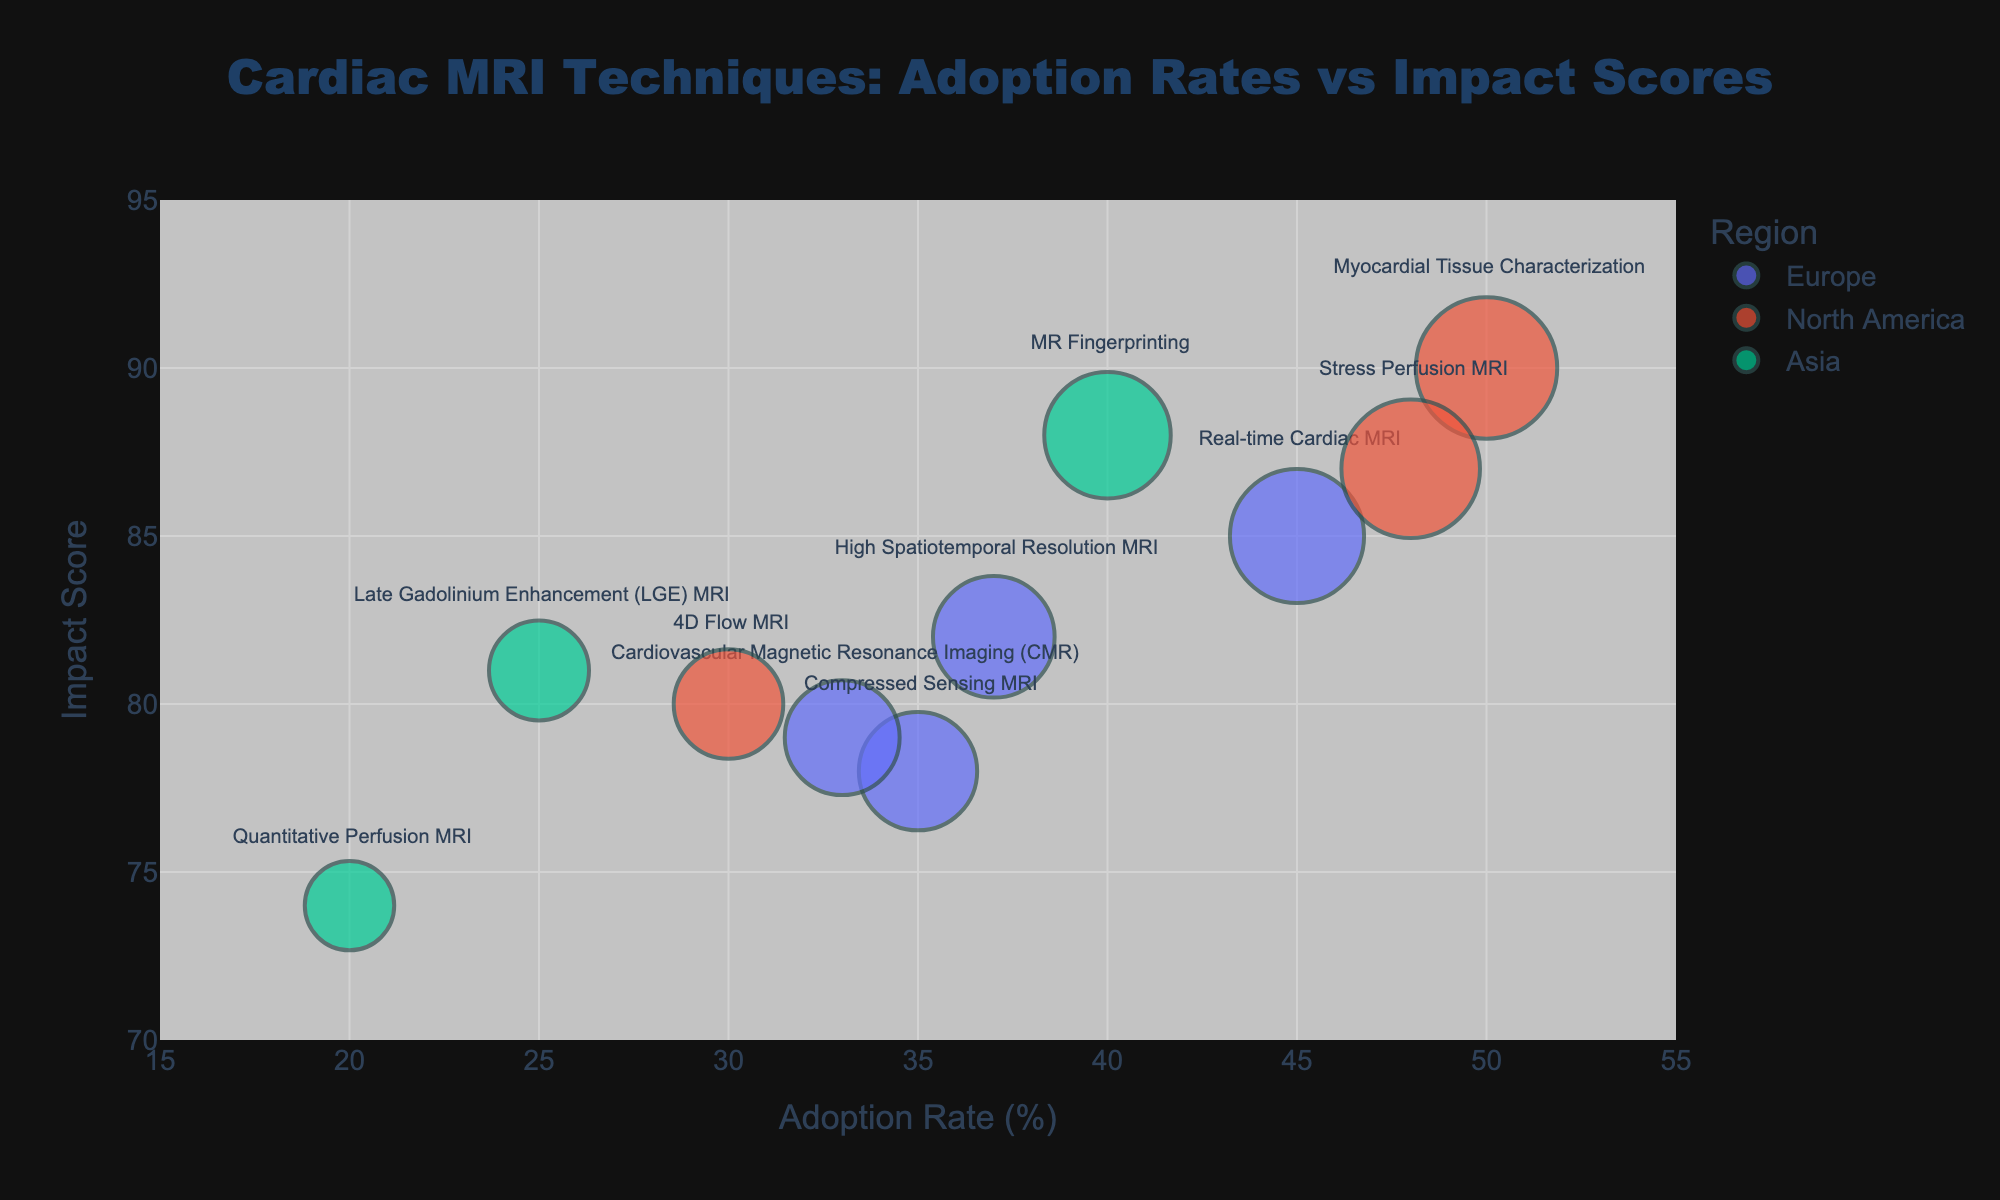How many unique techniques are depicted in the figure? There are a total of 10 unique techniques shown: Real-time Cardiac MRI, Compressed Sensing MRI, Myocardial Tissue Characterization, 4D Flow MRI, MR Fingerprinting, Quantitative Perfusion MRI, High Spatiotemporal Resolution MRI, Cardiovascular Magnetic Resonance Imaging (CMR), Stress Perfusion MRI, and Late Gadolinium Enhancement (LGE) MRI.
Answer: 10 Which region has the highest average Adoption Rate? To find the region with the highest average Adoption Rate, calculate the averages: Europe = (45+35+37+33)/4 = 37.5, North America = (50+30+48)/3 = 42.67, Asia = (40+20+25)/3 = 28.33. North America has the highest average Adoption Rate.
Answer: North America Which technique has the highest Impact Score? The highest Impact Score among the techniques is Myocardial Tissue Characterization with a score of 90.
Answer: Myocardial Tissue Characterization What is the range of Adoption Rates shown in the figure? The Adoption Rates range from the minimum value of 20% (Quantitative Perfusion MRI) to the maximum value of 50% (Myocardial Tissue Characterization). The range is 50 - 20 = 30%.
Answer: 30% Which country has the highest Adoption Rate for cardiac MRI techniques? The USA has the highest Adoption Rate for cardiac MRI techniques, with Myocardial Tissue Characterization at 50%.
Answer: USA What is the difference in Impact Scores between Real-time Cardiac MRI in Germany and Compressed Sensing MRI in France? The Impact Score for Real-time Cardiac MRI in Germany is 85, and for Compressed Sensing MRI in France is 78. The difference is 85 - 78 = 7.
Answer: 7 Are any techniques marked by all regions (Europe, North America, Asia) clustered closely together in terms of Impact Scores? By examining the bubble chart, it appears that techniques like Real-time Cardiac MRI (Europe: 85), Myocardial Tissue Characterization (North America: 90), and MR Fingerprinting (Asia: 88) are closely clustered around high Impact Scores (85-90).
Answer: Yes Which technique in Europe has the lowest Adoption Rate and what is its value? Cardiovascular Magnetic Resonance Imaging (CMR) in Sweden has the lowest Adoption Rate in Europe, which is 33%.
Answer: CMR (33%) What is the Adoption Rate of Quantitative Perfusion MRI technique and in which region and country is it used? The Adoption Rate of Quantitative Perfusion MRI is 20%. It is used in South Korea, which is in the Asia region.
Answer: 20%, Asia, South Korea Between Japan's MR Fingerprinting and South Korea's Quantitative Perfusion MRI, which technique has a higher Impact Score and by how much? MR Fingerprinting in Japan has an Impact Score of 88 and Quantitative Perfusion MRI in South Korea has an Impact Score of 74. The difference is 88 - 74 = 14.
Answer: MR Fingerprinting by 14 